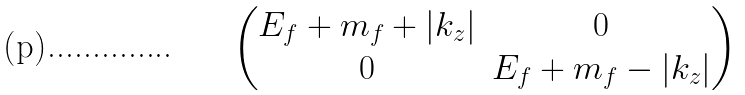<formula> <loc_0><loc_0><loc_500><loc_500>\begin{pmatrix} E _ { f } + m _ { f } + | k _ { z } | & 0 \\ 0 & E _ { f } + m _ { f } - | k _ { z } | \\ \end{pmatrix}</formula> 